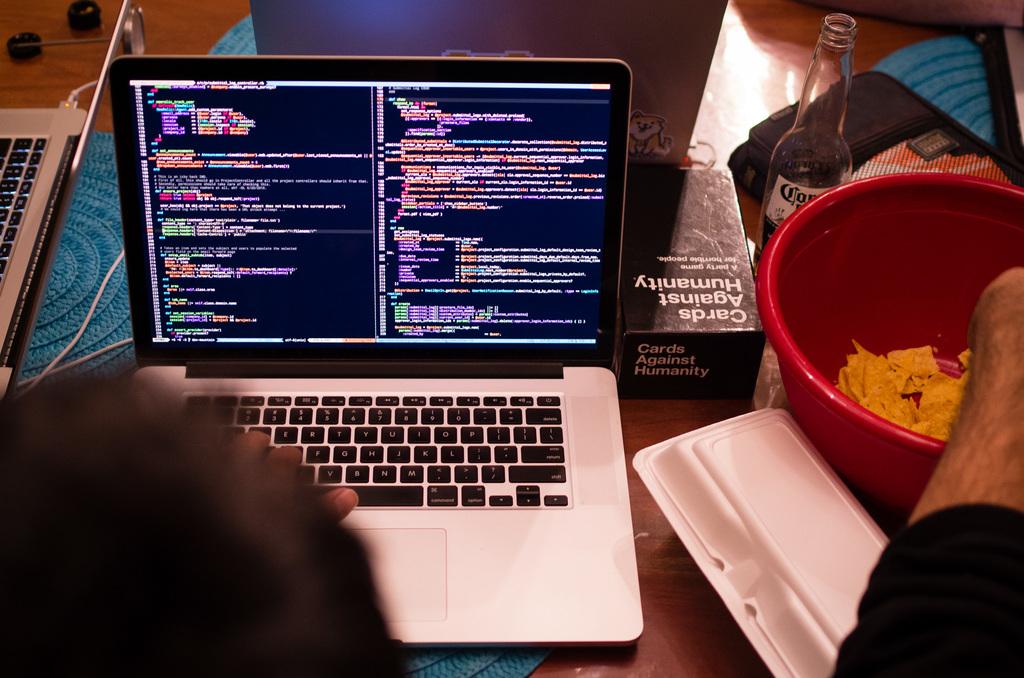What board game is the black box?
Your response must be concise. Cards against humanity. 